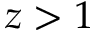<formula> <loc_0><loc_0><loc_500><loc_500>z > 1</formula> 